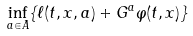Convert formula to latex. <formula><loc_0><loc_0><loc_500><loc_500>\inf _ { a \in A } \{ \ell ( t , x , a ) + G ^ { a } \varphi ( t , x ) \}</formula> 